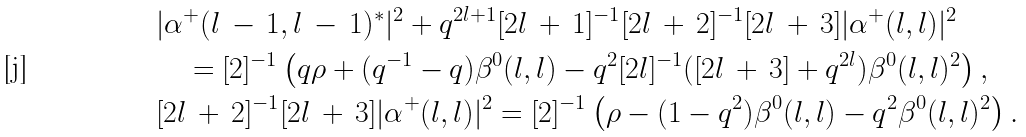<formula> <loc_0><loc_0><loc_500><loc_500>& | \alpha ^ { + } ( l \, - \, 1 , l \, - \, 1 ) ^ { \ast } | ^ { 2 } + q ^ { 2 l + 1 } [ 2 l \, + \, 1 ] ^ { - 1 } [ 2 l \, + \, 2 ] ^ { - 1 } [ 2 l \, + \, 3 ] | \alpha ^ { + } ( l , l ) | ^ { 2 } \\ & \quad = [ 2 ] ^ { - 1 } \left ( q \rho + ( q ^ { - 1 } - q ) \beta ^ { 0 } ( l , l ) - q ^ { 2 } [ 2 l ] ^ { - 1 } ( [ 2 l \, + \, 3 ] + q ^ { 2 l } ) \beta ^ { 0 } ( l , l ) ^ { 2 } \right ) , \\ & [ 2 l \, + \, 2 ] ^ { - 1 } [ 2 l \, + \, 3 ] | \alpha ^ { + } ( l , l ) | ^ { 2 } = [ 2 ] ^ { - 1 } \left ( \rho - ( 1 - q ^ { 2 } ) \beta ^ { 0 } ( l , l ) - q ^ { 2 } \beta ^ { 0 } ( l , l ) ^ { 2 } \right ) .</formula> 